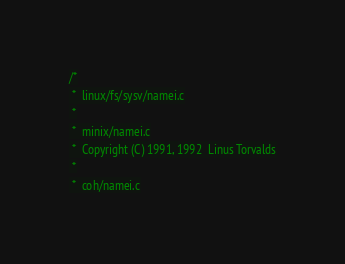Convert code to text. <code><loc_0><loc_0><loc_500><loc_500><_C_>/*
 *  linux/fs/sysv/namei.c
 *
 *  minix/namei.c
 *  Copyright (C) 1991, 1992  Linus Torvalds
 *
 *  coh/namei.c</code> 